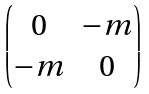<formula> <loc_0><loc_0><loc_500><loc_500>\begin{pmatrix} 0 & - m \\ - m & 0 \end{pmatrix}</formula> 